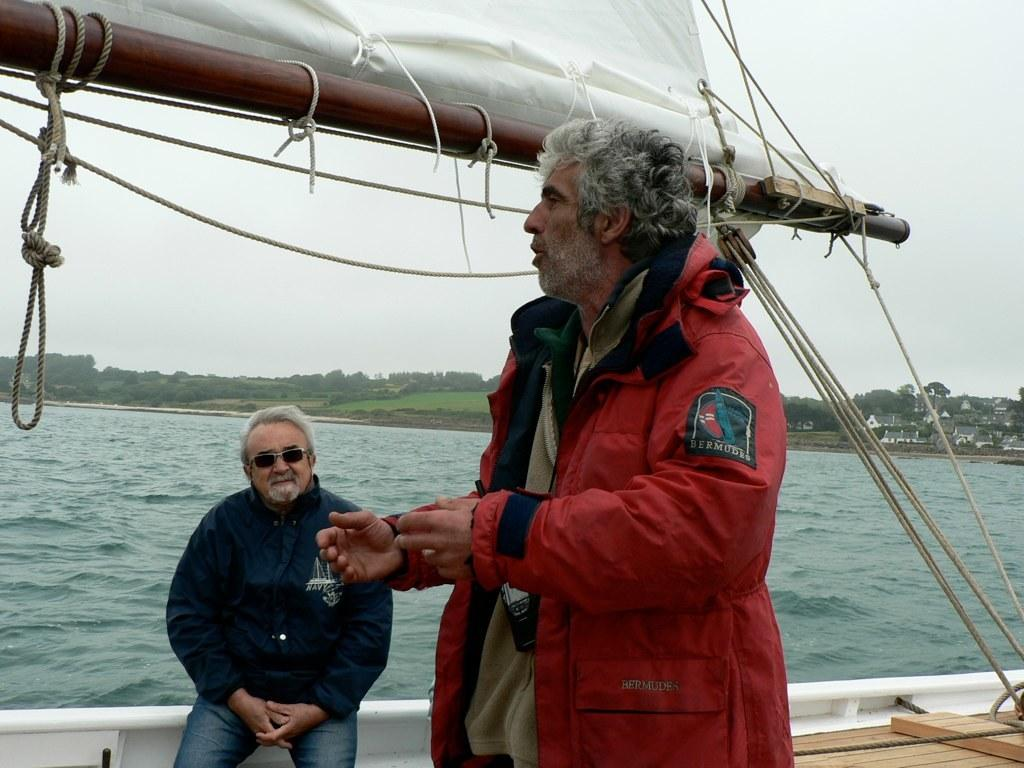<image>
Provide a brief description of the given image. Two men talking on a boat one wearing a red Bermudes jacket. 